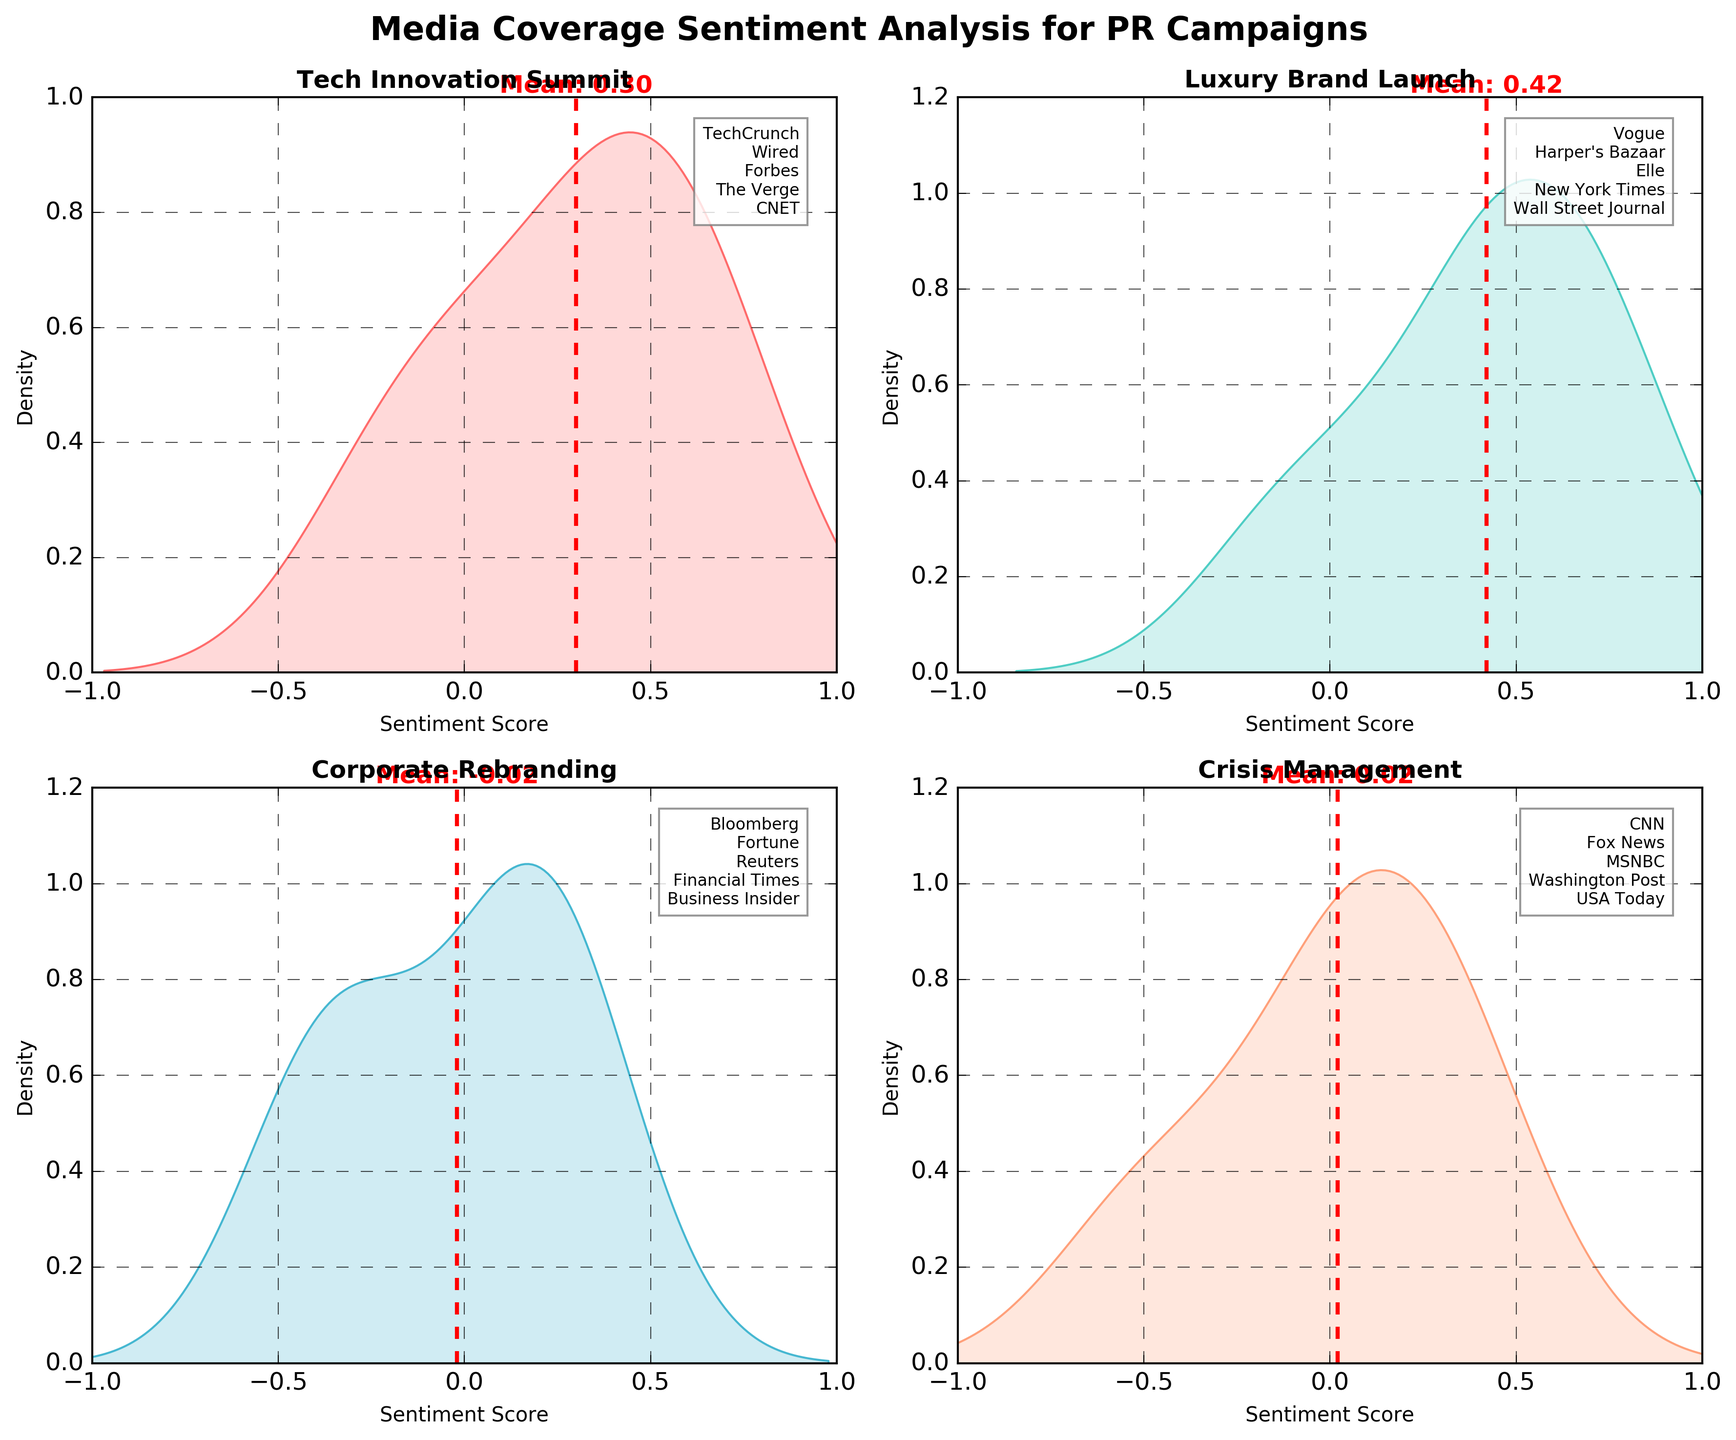What's the overall title of the figure? The overall title of the figure is located at the top of the plot. It states the main subject of the visualization.
Answer: Media Coverage Sentiment Analysis for PR Campaigns What are the four campaigns displayed in the subplots? The titles of the four campaigns are shown at the top of each subplot. The campaigns are "Tech Innovation Summit," "Luxury Brand Launch," "Corporate Rebranding," and "Crisis Management."
Answer: "Tech Innovation Summit," "Luxury Brand Launch," "Corporate Rebranding," "Crisis Management" Which campaign has the highest density peak? Look at the density peaks for each campaign. The subplot with the highest peak indicates the campaign with the highest density. The "Luxury Brand Launch" campaign has the highest density peak.
Answer: Luxury Brand Launch What is the mean sentiment score for the "Crisis Management" campaign? To find the mean sentiment score, look for the red dashed line in the "Crisis Management" subplot. The mean sentiment for "Crisis Management" can be read from the line and text annotation.
Answer: 0.02 Compare the mean sentiment scores between "Tech Innovation Summit" and "Corporate Rebranding." Which one is higher? Identify the red dashed lines representing the mean in each subplot and note the values. "Tech Innovation Summit" has a mean of 0.30, while "Corporate Rebranding" has a mean of -0.02.
Answer: Tech Innovation Summit Which publication is associated with the lowest sentiment score in the "Luxury Brand Launch" campaign? Check the annotations listing the publications in the "Luxury Brand Launch" subplot. The publication with the lowest sentiment score of -0.1 is the New York Times.
Answer: New York Times What is the x-axis range for each subplot? The x-axis range can be seen in the labels. For each subplot, it ranges from -1 to 1, indicating sentiment scores.
Answer: -1 to 1 Which campaign has sentiment scores spread across the most publications? Count the number of publications listed in each subplot. The "Crisis Management" campaign has the most publications listed, with five different publications.
Answer: Crisis Management Is there any campaign with a negative mean sentiment score? Look at the red dashed lines representing mean sentiment scores and check if any are below zero. "Corporate Rebranding" has a negative mean sentiment score.
Answer: Corporate Rebranding 